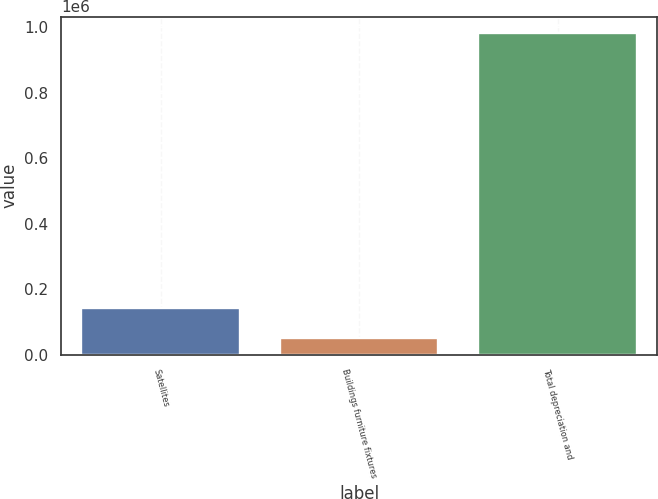<chart> <loc_0><loc_0><loc_500><loc_500><bar_chart><fcel>Satellites<fcel>Buildings furniture fixtures<fcel>Total depreciation and<nl><fcel>144308<fcel>51013<fcel>983965<nl></chart> 